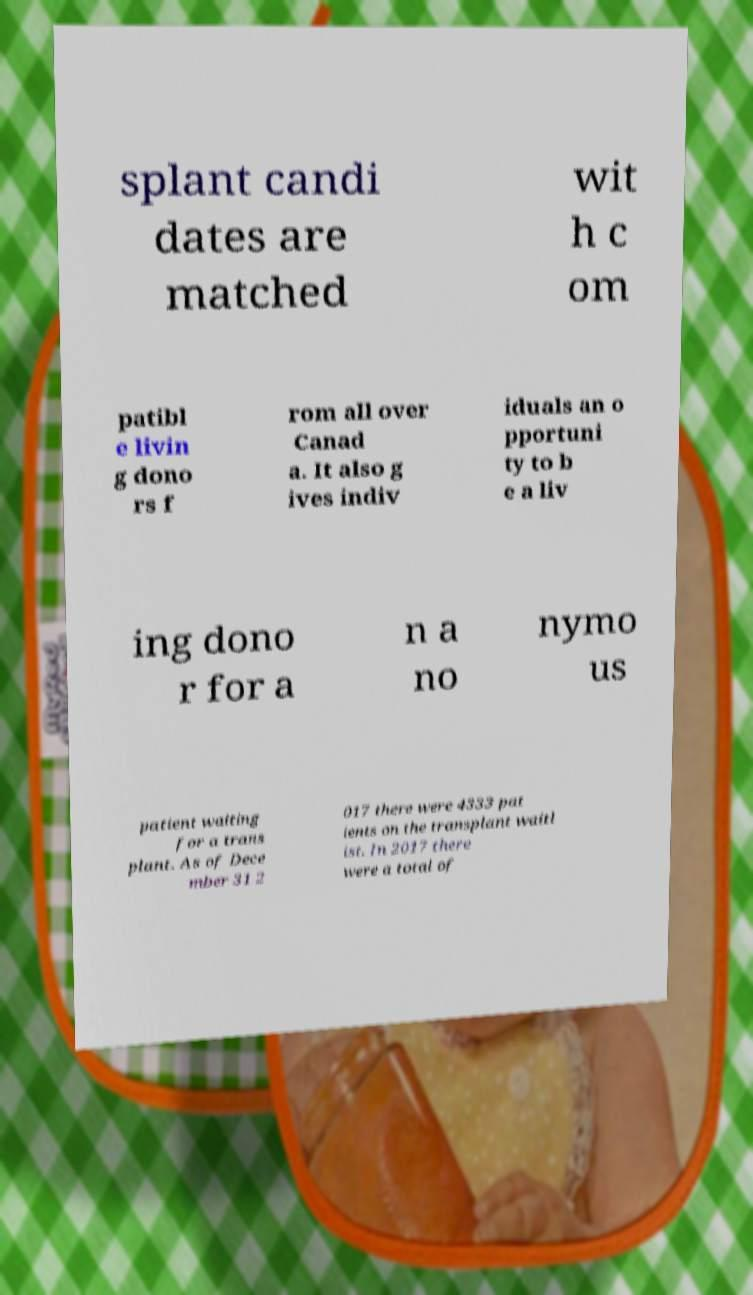Can you accurately transcribe the text from the provided image for me? splant candi dates are matched wit h c om patibl e livin g dono rs f rom all over Canad a. It also g ives indiv iduals an o pportuni ty to b e a liv ing dono r for a n a no nymo us patient waiting for a trans plant. As of Dece mber 31 2 017 there were 4333 pat ients on the transplant waitl ist. In 2017 there were a total of 